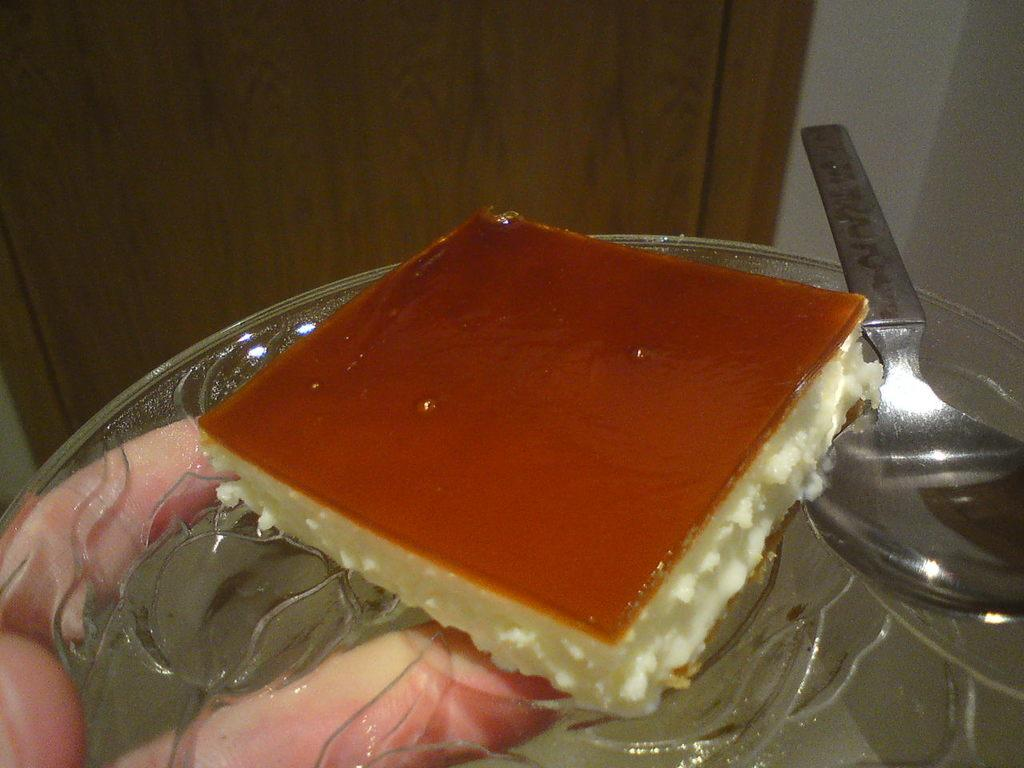What is being held by a person's hand in the image? There is a person's hand holding a plate in the image holding a plate. What is on the plate that is being held? The plate contains food. What utensil is present on the plate? There is a spoon in the plate. What can be seen in the background of the image? There is a door and a wall visible in the background of the image. What type of books can be seen on the bed in the image? There is no bed or books present in the image; it features a person's hand holding a plate with food and a spoon. 